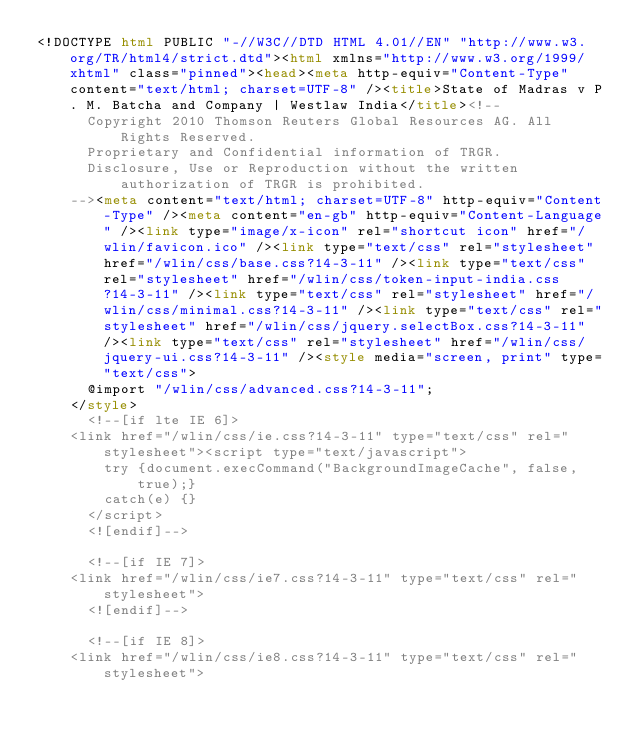<code> <loc_0><loc_0><loc_500><loc_500><_HTML_><!DOCTYPE html PUBLIC "-//W3C//DTD HTML 4.01//EN" "http://www.w3.org/TR/html4/strict.dtd"><html xmlns="http://www.w3.org/1999/xhtml" class="pinned"><head><meta http-equiv="Content-Type" content="text/html; charset=UTF-8" /><title>State of Madras v P. M. Batcha and Company | Westlaw India</title><!--
      Copyright 2010 Thomson Reuters Global Resources AG. All Rights Reserved.
      Proprietary and Confidential information of TRGR.
      Disclosure, Use or Reproduction without the written authorization of TRGR is prohibited.
    --><meta content="text/html; charset=UTF-8" http-equiv="Content-Type" /><meta content="en-gb" http-equiv="Content-Language" /><link type="image/x-icon" rel="shortcut icon" href="/wlin/favicon.ico" /><link type="text/css" rel="stylesheet" href="/wlin/css/base.css?14-3-11" /><link type="text/css" rel="stylesheet" href="/wlin/css/token-input-india.css?14-3-11" /><link type="text/css" rel="stylesheet" href="/wlin/css/minimal.css?14-3-11" /><link type="text/css" rel="stylesheet" href="/wlin/css/jquery.selectBox.css?14-3-11" /><link type="text/css" rel="stylesheet" href="/wlin/css/jquery-ui.css?14-3-11" /><style media="screen, print" type="text/css">
			@import "/wlin/css/advanced.css?14-3-11";
		</style>
			<!--[if lte IE 6]>
		<link href="/wlin/css/ie.css?14-3-11" type="text/css" rel="stylesheet"><script type="text/javascript">
				try {document.execCommand("BackgroundImageCache", false, true);}
				catch(e) {}
			</script>
			<![endif]-->
		
			<!--[if IE 7]>
		<link href="/wlin/css/ie7.css?14-3-11" type="text/css" rel="stylesheet">
			<![endif]-->
		
			<!--[if IE 8]>
		<link href="/wlin/css/ie8.css?14-3-11" type="text/css" rel="stylesheet"></code> 